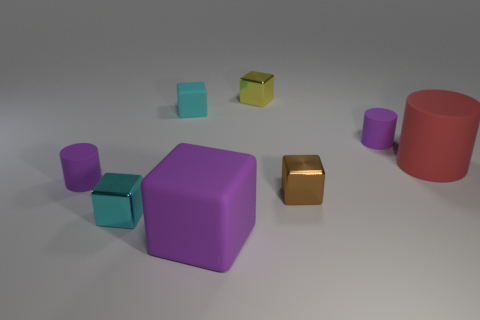Subtract all purple cylinders. How many cylinders are left? 1 Subtract all brown cubes. How many cubes are left? 4 Subtract all purple cylinders. How many blue blocks are left? 0 Add 1 objects. How many objects exist? 9 Subtract 4 cubes. How many cubes are left? 1 Add 5 purple rubber objects. How many purple rubber objects exist? 8 Subtract 0 cyan balls. How many objects are left? 8 Subtract all cylinders. How many objects are left? 5 Subtract all blue cubes. Subtract all brown spheres. How many cubes are left? 5 Subtract all brown things. Subtract all matte cylinders. How many objects are left? 4 